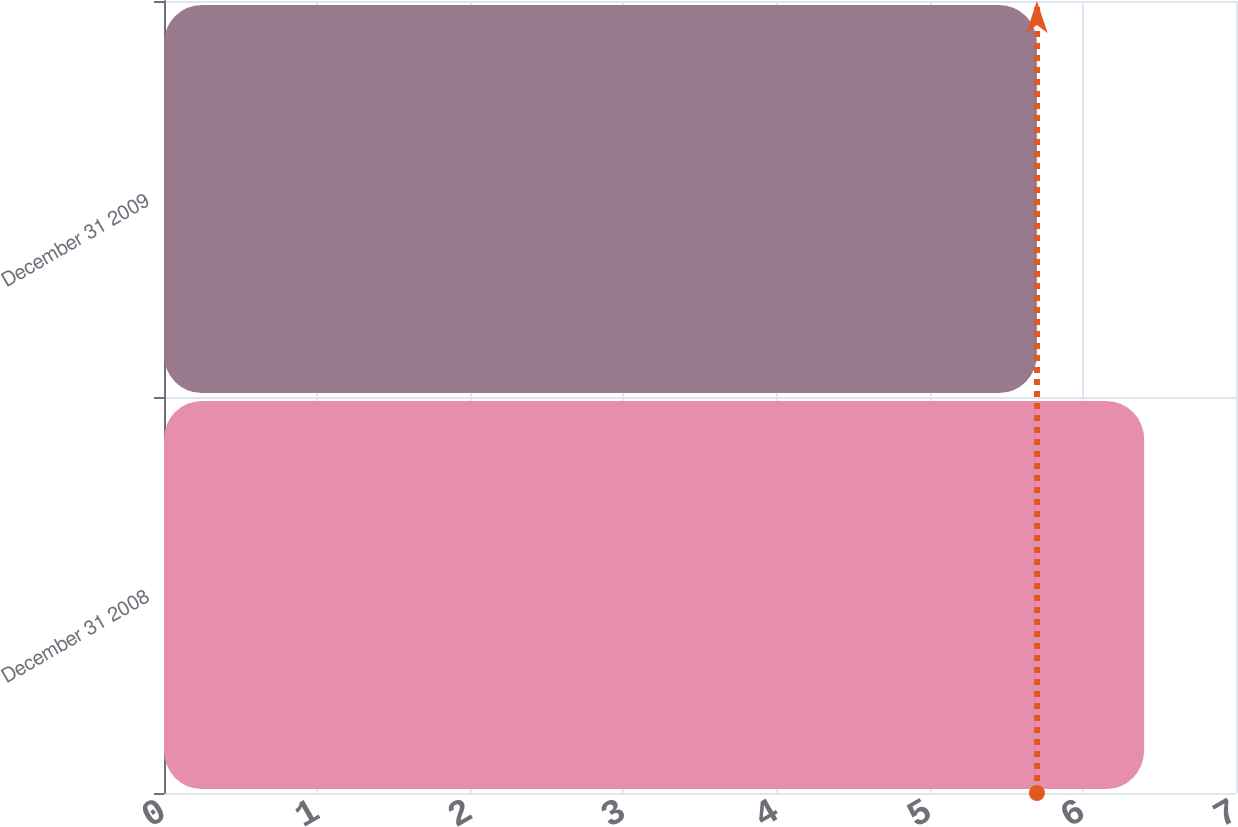Convert chart to OTSL. <chart><loc_0><loc_0><loc_500><loc_500><bar_chart><fcel>December 31 2008<fcel>December 31 2009<nl><fcel>6.4<fcel>5.7<nl></chart> 